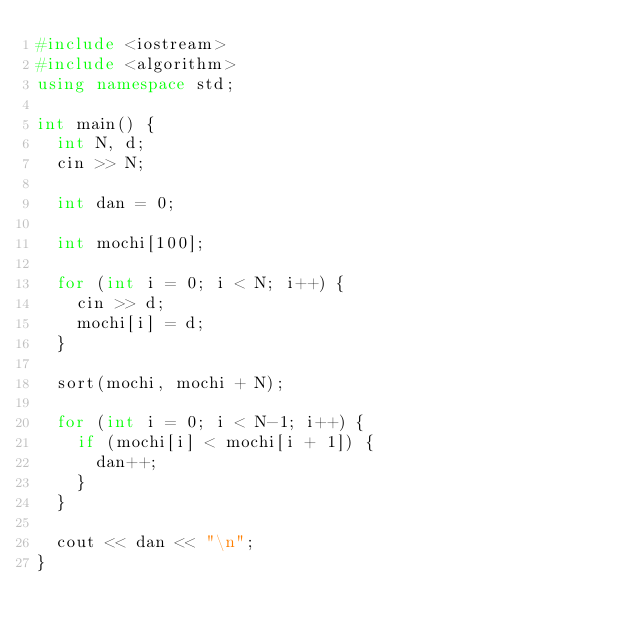<code> <loc_0><loc_0><loc_500><loc_500><_C++_>#include <iostream>
#include <algorithm>
using namespace std;

int main() {
	int N, d;
	cin >> N;

	int dan = 0;

	int mochi[100];

	for (int i = 0; i < N; i++) {
		cin >> d;
		mochi[i] = d;
	}

	sort(mochi, mochi + N);

	for (int i = 0; i < N-1; i++) {
		if (mochi[i] < mochi[i + 1]) {
			dan++;
		}
	}

	cout << dan << "\n";
}</code> 